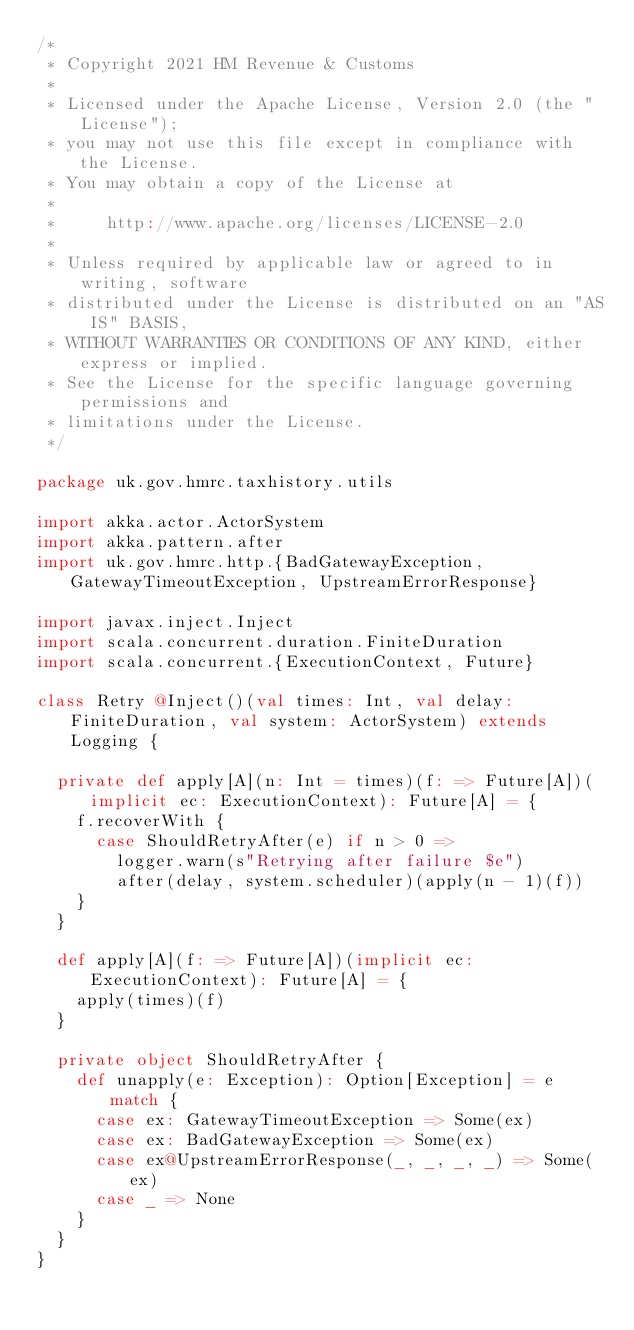Convert code to text. <code><loc_0><loc_0><loc_500><loc_500><_Scala_>/*
 * Copyright 2021 HM Revenue & Customs
 *
 * Licensed under the Apache License, Version 2.0 (the "License");
 * you may not use this file except in compliance with the License.
 * You may obtain a copy of the License at
 *
 *     http://www.apache.org/licenses/LICENSE-2.0
 *
 * Unless required by applicable law or agreed to in writing, software
 * distributed under the License is distributed on an "AS IS" BASIS,
 * WITHOUT WARRANTIES OR CONDITIONS OF ANY KIND, either express or implied.
 * See the License for the specific language governing permissions and
 * limitations under the License.
 */

package uk.gov.hmrc.taxhistory.utils

import akka.actor.ActorSystem
import akka.pattern.after
import uk.gov.hmrc.http.{BadGatewayException, GatewayTimeoutException, UpstreamErrorResponse}

import javax.inject.Inject
import scala.concurrent.duration.FiniteDuration
import scala.concurrent.{ExecutionContext, Future}

class Retry @Inject()(val times: Int, val delay: FiniteDuration, val system: ActorSystem) extends Logging {

  private def apply[A](n: Int = times)(f: => Future[A])(implicit ec: ExecutionContext): Future[A] = {
    f.recoverWith {
      case ShouldRetryAfter(e) if n > 0 =>
        logger.warn(s"Retrying after failure $e")
        after(delay, system.scheduler)(apply(n - 1)(f))
    }
  }

  def apply[A](f: => Future[A])(implicit ec: ExecutionContext): Future[A] = {
    apply(times)(f)
  }

  private object ShouldRetryAfter {
    def unapply(e: Exception): Option[Exception] = e match {
      case ex: GatewayTimeoutException => Some(ex)
      case ex: BadGatewayException => Some(ex)
      case ex@UpstreamErrorResponse(_, _, _, _) => Some(ex)
      case _ => None
    }
  }
}
</code> 